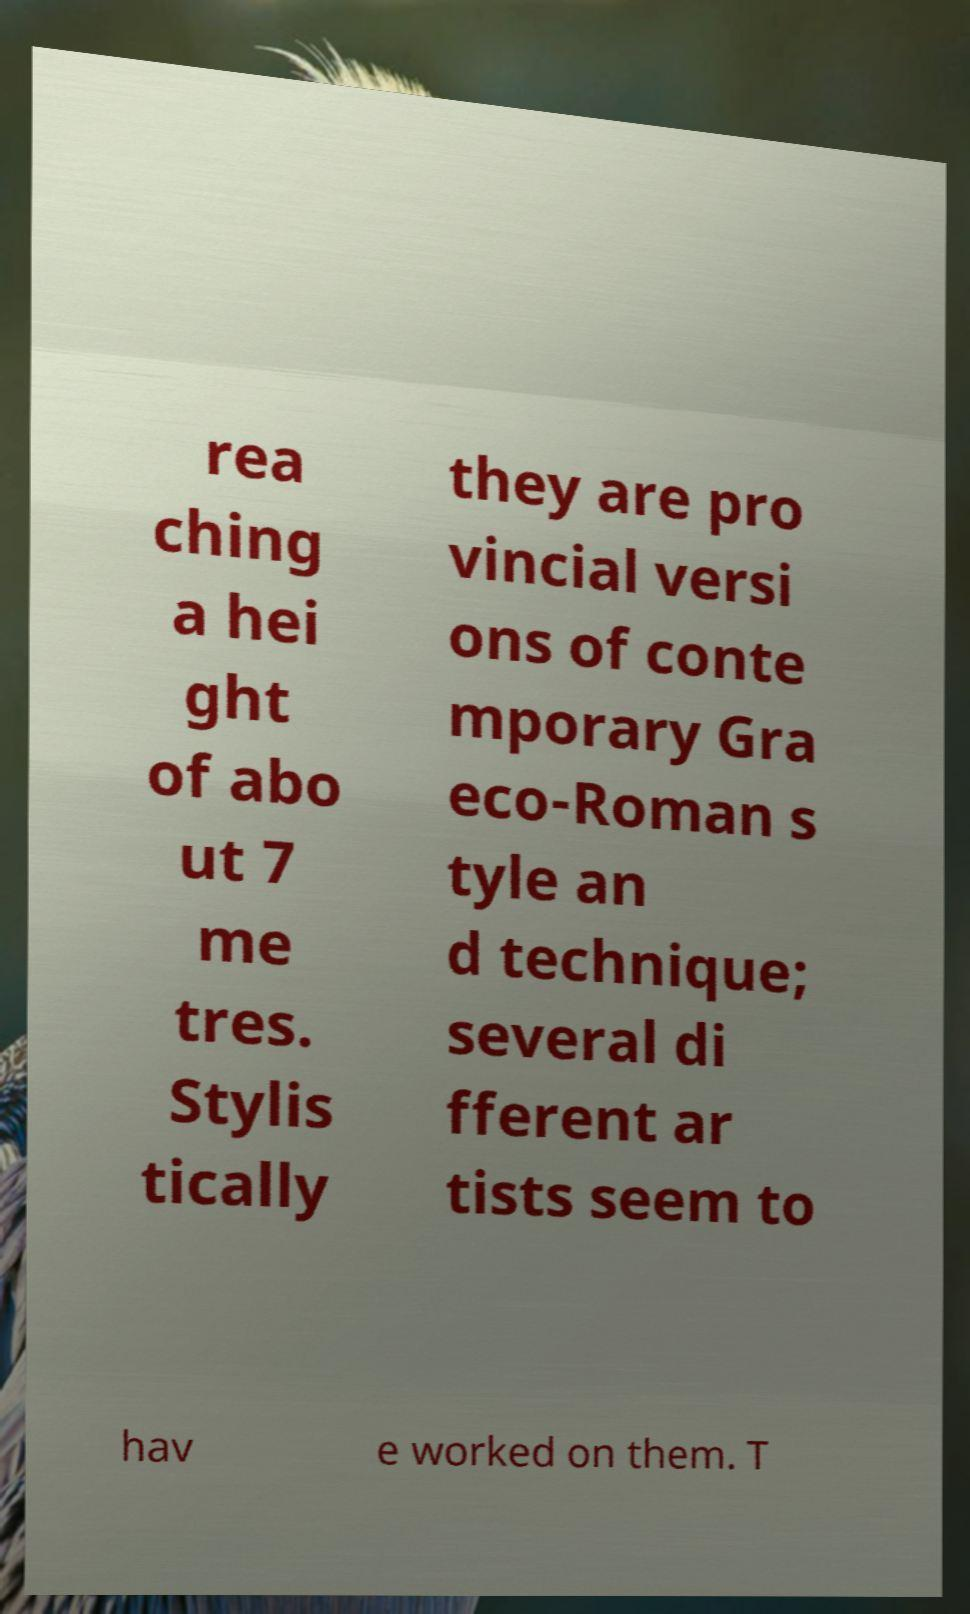I need the written content from this picture converted into text. Can you do that? rea ching a hei ght of abo ut 7 me tres. Stylis tically they are pro vincial versi ons of conte mporary Gra eco-Roman s tyle an d technique; several di fferent ar tists seem to hav e worked on them. T 